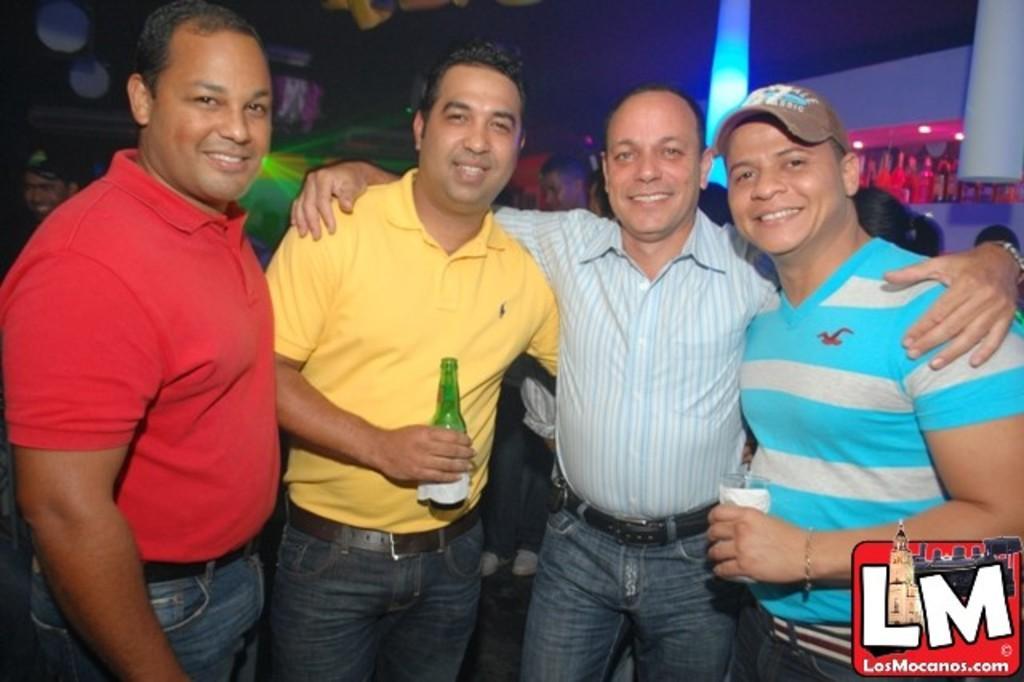How would you summarize this image in a sentence or two? This picture describes about group of people, few people are smiling, in the middle of the image we can see a man, he is holding a bottle, in the background we can find few bottles in the racks and lights. 